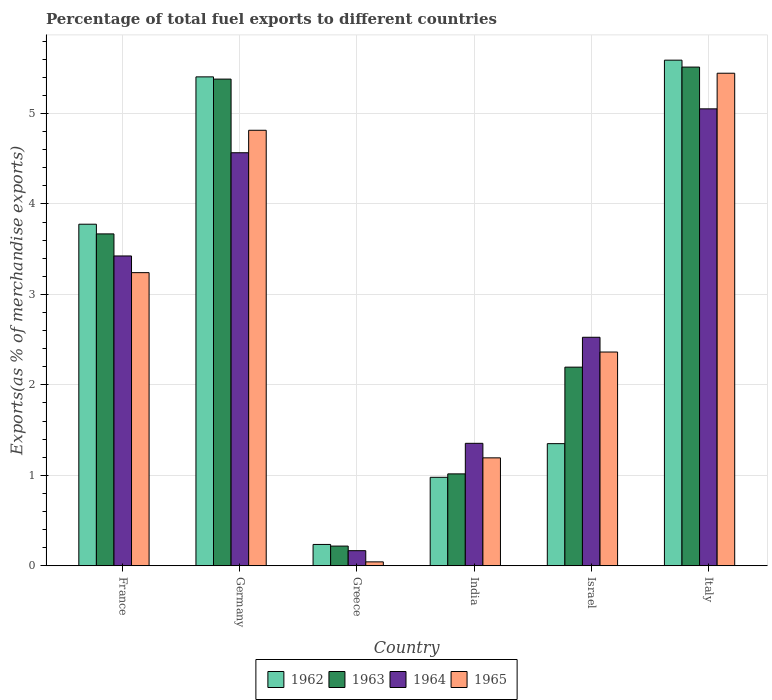How many different coloured bars are there?
Your answer should be very brief. 4. How many bars are there on the 2nd tick from the right?
Ensure brevity in your answer.  4. What is the percentage of exports to different countries in 1963 in France?
Your answer should be compact. 3.67. Across all countries, what is the maximum percentage of exports to different countries in 1962?
Keep it short and to the point. 5.59. Across all countries, what is the minimum percentage of exports to different countries in 1962?
Your answer should be compact. 0.24. In which country was the percentage of exports to different countries in 1965 minimum?
Offer a terse response. Greece. What is the total percentage of exports to different countries in 1962 in the graph?
Provide a succinct answer. 17.34. What is the difference between the percentage of exports to different countries in 1962 in India and that in Italy?
Offer a very short reply. -4.61. What is the difference between the percentage of exports to different countries in 1962 in Israel and the percentage of exports to different countries in 1965 in India?
Give a very brief answer. 0.16. What is the average percentage of exports to different countries in 1965 per country?
Offer a terse response. 2.85. What is the difference between the percentage of exports to different countries of/in 1963 and percentage of exports to different countries of/in 1962 in Israel?
Keep it short and to the point. 0.85. In how many countries, is the percentage of exports to different countries in 1965 greater than 5.4 %?
Provide a short and direct response. 1. What is the ratio of the percentage of exports to different countries in 1964 in Greece to that in Israel?
Offer a terse response. 0.07. Is the difference between the percentage of exports to different countries in 1963 in Greece and Italy greater than the difference between the percentage of exports to different countries in 1962 in Greece and Italy?
Make the answer very short. Yes. What is the difference between the highest and the second highest percentage of exports to different countries in 1965?
Provide a short and direct response. -1.57. What is the difference between the highest and the lowest percentage of exports to different countries in 1964?
Provide a short and direct response. 4.88. Is it the case that in every country, the sum of the percentage of exports to different countries in 1964 and percentage of exports to different countries in 1965 is greater than the sum of percentage of exports to different countries in 1963 and percentage of exports to different countries in 1962?
Give a very brief answer. No. What does the 3rd bar from the right in Greece represents?
Provide a succinct answer. 1963. Is it the case that in every country, the sum of the percentage of exports to different countries in 1965 and percentage of exports to different countries in 1964 is greater than the percentage of exports to different countries in 1962?
Offer a very short reply. No. How many bars are there?
Provide a succinct answer. 24. How many countries are there in the graph?
Give a very brief answer. 6. Does the graph contain any zero values?
Provide a succinct answer. No. What is the title of the graph?
Your response must be concise. Percentage of total fuel exports to different countries. Does "1993" appear as one of the legend labels in the graph?
Provide a short and direct response. No. What is the label or title of the Y-axis?
Provide a succinct answer. Exports(as % of merchandise exports). What is the Exports(as % of merchandise exports) in 1962 in France?
Ensure brevity in your answer.  3.78. What is the Exports(as % of merchandise exports) of 1963 in France?
Offer a terse response. 3.67. What is the Exports(as % of merchandise exports) of 1964 in France?
Your response must be concise. 3.43. What is the Exports(as % of merchandise exports) in 1965 in France?
Your answer should be very brief. 3.24. What is the Exports(as % of merchandise exports) in 1962 in Germany?
Offer a terse response. 5.4. What is the Exports(as % of merchandise exports) of 1963 in Germany?
Offer a terse response. 5.38. What is the Exports(as % of merchandise exports) in 1964 in Germany?
Your answer should be compact. 4.57. What is the Exports(as % of merchandise exports) in 1965 in Germany?
Give a very brief answer. 4.81. What is the Exports(as % of merchandise exports) of 1962 in Greece?
Your answer should be very brief. 0.24. What is the Exports(as % of merchandise exports) in 1963 in Greece?
Provide a succinct answer. 0.22. What is the Exports(as % of merchandise exports) in 1964 in Greece?
Your response must be concise. 0.17. What is the Exports(as % of merchandise exports) in 1965 in Greece?
Your response must be concise. 0.04. What is the Exports(as % of merchandise exports) in 1962 in India?
Offer a terse response. 0.98. What is the Exports(as % of merchandise exports) of 1963 in India?
Your answer should be very brief. 1.02. What is the Exports(as % of merchandise exports) in 1964 in India?
Provide a short and direct response. 1.35. What is the Exports(as % of merchandise exports) of 1965 in India?
Keep it short and to the point. 1.19. What is the Exports(as % of merchandise exports) in 1962 in Israel?
Give a very brief answer. 1.35. What is the Exports(as % of merchandise exports) of 1963 in Israel?
Make the answer very short. 2.2. What is the Exports(as % of merchandise exports) in 1964 in Israel?
Your response must be concise. 2.53. What is the Exports(as % of merchandise exports) of 1965 in Israel?
Give a very brief answer. 2.36. What is the Exports(as % of merchandise exports) of 1962 in Italy?
Your answer should be compact. 5.59. What is the Exports(as % of merchandise exports) of 1963 in Italy?
Ensure brevity in your answer.  5.51. What is the Exports(as % of merchandise exports) of 1964 in Italy?
Offer a very short reply. 5.05. What is the Exports(as % of merchandise exports) of 1965 in Italy?
Your answer should be compact. 5.45. Across all countries, what is the maximum Exports(as % of merchandise exports) in 1962?
Offer a very short reply. 5.59. Across all countries, what is the maximum Exports(as % of merchandise exports) of 1963?
Offer a very short reply. 5.51. Across all countries, what is the maximum Exports(as % of merchandise exports) in 1964?
Make the answer very short. 5.05. Across all countries, what is the maximum Exports(as % of merchandise exports) in 1965?
Your response must be concise. 5.45. Across all countries, what is the minimum Exports(as % of merchandise exports) of 1962?
Offer a terse response. 0.24. Across all countries, what is the minimum Exports(as % of merchandise exports) in 1963?
Offer a very short reply. 0.22. Across all countries, what is the minimum Exports(as % of merchandise exports) in 1964?
Your response must be concise. 0.17. Across all countries, what is the minimum Exports(as % of merchandise exports) in 1965?
Keep it short and to the point. 0.04. What is the total Exports(as % of merchandise exports) in 1962 in the graph?
Provide a succinct answer. 17.34. What is the total Exports(as % of merchandise exports) of 1963 in the graph?
Provide a short and direct response. 17.99. What is the total Exports(as % of merchandise exports) of 1964 in the graph?
Offer a terse response. 17.09. What is the total Exports(as % of merchandise exports) in 1965 in the graph?
Provide a short and direct response. 17.1. What is the difference between the Exports(as % of merchandise exports) in 1962 in France and that in Germany?
Give a very brief answer. -1.63. What is the difference between the Exports(as % of merchandise exports) of 1963 in France and that in Germany?
Your answer should be very brief. -1.71. What is the difference between the Exports(as % of merchandise exports) of 1964 in France and that in Germany?
Ensure brevity in your answer.  -1.14. What is the difference between the Exports(as % of merchandise exports) in 1965 in France and that in Germany?
Make the answer very short. -1.57. What is the difference between the Exports(as % of merchandise exports) in 1962 in France and that in Greece?
Your response must be concise. 3.54. What is the difference between the Exports(as % of merchandise exports) in 1963 in France and that in Greece?
Ensure brevity in your answer.  3.45. What is the difference between the Exports(as % of merchandise exports) in 1964 in France and that in Greece?
Your answer should be compact. 3.26. What is the difference between the Exports(as % of merchandise exports) of 1965 in France and that in Greece?
Give a very brief answer. 3.2. What is the difference between the Exports(as % of merchandise exports) in 1962 in France and that in India?
Your response must be concise. 2.8. What is the difference between the Exports(as % of merchandise exports) of 1963 in France and that in India?
Provide a short and direct response. 2.65. What is the difference between the Exports(as % of merchandise exports) of 1964 in France and that in India?
Your answer should be very brief. 2.07. What is the difference between the Exports(as % of merchandise exports) in 1965 in France and that in India?
Offer a terse response. 2.05. What is the difference between the Exports(as % of merchandise exports) of 1962 in France and that in Israel?
Offer a very short reply. 2.43. What is the difference between the Exports(as % of merchandise exports) of 1963 in France and that in Israel?
Give a very brief answer. 1.47. What is the difference between the Exports(as % of merchandise exports) in 1964 in France and that in Israel?
Your answer should be compact. 0.9. What is the difference between the Exports(as % of merchandise exports) of 1965 in France and that in Israel?
Give a very brief answer. 0.88. What is the difference between the Exports(as % of merchandise exports) of 1962 in France and that in Italy?
Give a very brief answer. -1.81. What is the difference between the Exports(as % of merchandise exports) in 1963 in France and that in Italy?
Ensure brevity in your answer.  -1.84. What is the difference between the Exports(as % of merchandise exports) of 1964 in France and that in Italy?
Your answer should be very brief. -1.63. What is the difference between the Exports(as % of merchandise exports) in 1965 in France and that in Italy?
Offer a terse response. -2.2. What is the difference between the Exports(as % of merchandise exports) in 1962 in Germany and that in Greece?
Provide a short and direct response. 5.17. What is the difference between the Exports(as % of merchandise exports) in 1963 in Germany and that in Greece?
Your answer should be compact. 5.16. What is the difference between the Exports(as % of merchandise exports) in 1964 in Germany and that in Greece?
Your answer should be compact. 4.4. What is the difference between the Exports(as % of merchandise exports) of 1965 in Germany and that in Greece?
Your answer should be compact. 4.77. What is the difference between the Exports(as % of merchandise exports) in 1962 in Germany and that in India?
Make the answer very short. 4.43. What is the difference between the Exports(as % of merchandise exports) in 1963 in Germany and that in India?
Give a very brief answer. 4.36. What is the difference between the Exports(as % of merchandise exports) of 1964 in Germany and that in India?
Your answer should be compact. 3.21. What is the difference between the Exports(as % of merchandise exports) in 1965 in Germany and that in India?
Provide a short and direct response. 3.62. What is the difference between the Exports(as % of merchandise exports) of 1962 in Germany and that in Israel?
Give a very brief answer. 4.05. What is the difference between the Exports(as % of merchandise exports) in 1963 in Germany and that in Israel?
Give a very brief answer. 3.18. What is the difference between the Exports(as % of merchandise exports) in 1964 in Germany and that in Israel?
Ensure brevity in your answer.  2.04. What is the difference between the Exports(as % of merchandise exports) in 1965 in Germany and that in Israel?
Your response must be concise. 2.45. What is the difference between the Exports(as % of merchandise exports) in 1962 in Germany and that in Italy?
Give a very brief answer. -0.18. What is the difference between the Exports(as % of merchandise exports) in 1963 in Germany and that in Italy?
Provide a succinct answer. -0.13. What is the difference between the Exports(as % of merchandise exports) of 1964 in Germany and that in Italy?
Provide a short and direct response. -0.49. What is the difference between the Exports(as % of merchandise exports) of 1965 in Germany and that in Italy?
Offer a terse response. -0.63. What is the difference between the Exports(as % of merchandise exports) of 1962 in Greece and that in India?
Your response must be concise. -0.74. What is the difference between the Exports(as % of merchandise exports) of 1963 in Greece and that in India?
Provide a short and direct response. -0.8. What is the difference between the Exports(as % of merchandise exports) in 1964 in Greece and that in India?
Offer a terse response. -1.19. What is the difference between the Exports(as % of merchandise exports) of 1965 in Greece and that in India?
Your response must be concise. -1.15. What is the difference between the Exports(as % of merchandise exports) in 1962 in Greece and that in Israel?
Provide a short and direct response. -1.11. What is the difference between the Exports(as % of merchandise exports) of 1963 in Greece and that in Israel?
Provide a succinct answer. -1.98. What is the difference between the Exports(as % of merchandise exports) in 1964 in Greece and that in Israel?
Make the answer very short. -2.36. What is the difference between the Exports(as % of merchandise exports) of 1965 in Greece and that in Israel?
Keep it short and to the point. -2.32. What is the difference between the Exports(as % of merchandise exports) of 1962 in Greece and that in Italy?
Give a very brief answer. -5.35. What is the difference between the Exports(as % of merchandise exports) of 1963 in Greece and that in Italy?
Provide a succinct answer. -5.3. What is the difference between the Exports(as % of merchandise exports) in 1964 in Greece and that in Italy?
Keep it short and to the point. -4.88. What is the difference between the Exports(as % of merchandise exports) in 1965 in Greece and that in Italy?
Ensure brevity in your answer.  -5.4. What is the difference between the Exports(as % of merchandise exports) of 1962 in India and that in Israel?
Provide a short and direct response. -0.37. What is the difference between the Exports(as % of merchandise exports) in 1963 in India and that in Israel?
Provide a short and direct response. -1.18. What is the difference between the Exports(as % of merchandise exports) of 1964 in India and that in Israel?
Provide a short and direct response. -1.17. What is the difference between the Exports(as % of merchandise exports) in 1965 in India and that in Israel?
Keep it short and to the point. -1.17. What is the difference between the Exports(as % of merchandise exports) of 1962 in India and that in Italy?
Keep it short and to the point. -4.61. What is the difference between the Exports(as % of merchandise exports) of 1963 in India and that in Italy?
Keep it short and to the point. -4.5. What is the difference between the Exports(as % of merchandise exports) of 1964 in India and that in Italy?
Ensure brevity in your answer.  -3.7. What is the difference between the Exports(as % of merchandise exports) in 1965 in India and that in Italy?
Offer a very short reply. -4.25. What is the difference between the Exports(as % of merchandise exports) in 1962 in Israel and that in Italy?
Ensure brevity in your answer.  -4.24. What is the difference between the Exports(as % of merchandise exports) in 1963 in Israel and that in Italy?
Give a very brief answer. -3.32. What is the difference between the Exports(as % of merchandise exports) in 1964 in Israel and that in Italy?
Keep it short and to the point. -2.53. What is the difference between the Exports(as % of merchandise exports) in 1965 in Israel and that in Italy?
Give a very brief answer. -3.08. What is the difference between the Exports(as % of merchandise exports) in 1962 in France and the Exports(as % of merchandise exports) in 1963 in Germany?
Offer a terse response. -1.6. What is the difference between the Exports(as % of merchandise exports) of 1962 in France and the Exports(as % of merchandise exports) of 1964 in Germany?
Your answer should be very brief. -0.79. What is the difference between the Exports(as % of merchandise exports) in 1962 in France and the Exports(as % of merchandise exports) in 1965 in Germany?
Give a very brief answer. -1.04. What is the difference between the Exports(as % of merchandise exports) in 1963 in France and the Exports(as % of merchandise exports) in 1964 in Germany?
Give a very brief answer. -0.9. What is the difference between the Exports(as % of merchandise exports) of 1963 in France and the Exports(as % of merchandise exports) of 1965 in Germany?
Offer a very short reply. -1.15. What is the difference between the Exports(as % of merchandise exports) of 1964 in France and the Exports(as % of merchandise exports) of 1965 in Germany?
Offer a terse response. -1.39. What is the difference between the Exports(as % of merchandise exports) of 1962 in France and the Exports(as % of merchandise exports) of 1963 in Greece?
Your answer should be very brief. 3.56. What is the difference between the Exports(as % of merchandise exports) of 1962 in France and the Exports(as % of merchandise exports) of 1964 in Greece?
Offer a very short reply. 3.61. What is the difference between the Exports(as % of merchandise exports) in 1962 in France and the Exports(as % of merchandise exports) in 1965 in Greece?
Provide a short and direct response. 3.73. What is the difference between the Exports(as % of merchandise exports) in 1963 in France and the Exports(as % of merchandise exports) in 1964 in Greece?
Provide a short and direct response. 3.5. What is the difference between the Exports(as % of merchandise exports) in 1963 in France and the Exports(as % of merchandise exports) in 1965 in Greece?
Your response must be concise. 3.63. What is the difference between the Exports(as % of merchandise exports) of 1964 in France and the Exports(as % of merchandise exports) of 1965 in Greece?
Keep it short and to the point. 3.38. What is the difference between the Exports(as % of merchandise exports) in 1962 in France and the Exports(as % of merchandise exports) in 1963 in India?
Give a very brief answer. 2.76. What is the difference between the Exports(as % of merchandise exports) of 1962 in France and the Exports(as % of merchandise exports) of 1964 in India?
Ensure brevity in your answer.  2.42. What is the difference between the Exports(as % of merchandise exports) in 1962 in France and the Exports(as % of merchandise exports) in 1965 in India?
Offer a terse response. 2.58. What is the difference between the Exports(as % of merchandise exports) in 1963 in France and the Exports(as % of merchandise exports) in 1964 in India?
Provide a short and direct response. 2.32. What is the difference between the Exports(as % of merchandise exports) of 1963 in France and the Exports(as % of merchandise exports) of 1965 in India?
Your response must be concise. 2.48. What is the difference between the Exports(as % of merchandise exports) of 1964 in France and the Exports(as % of merchandise exports) of 1965 in India?
Provide a short and direct response. 2.23. What is the difference between the Exports(as % of merchandise exports) in 1962 in France and the Exports(as % of merchandise exports) in 1963 in Israel?
Your response must be concise. 1.58. What is the difference between the Exports(as % of merchandise exports) in 1962 in France and the Exports(as % of merchandise exports) in 1964 in Israel?
Your answer should be very brief. 1.25. What is the difference between the Exports(as % of merchandise exports) of 1962 in France and the Exports(as % of merchandise exports) of 1965 in Israel?
Offer a very short reply. 1.41. What is the difference between the Exports(as % of merchandise exports) in 1963 in France and the Exports(as % of merchandise exports) in 1964 in Israel?
Your answer should be compact. 1.14. What is the difference between the Exports(as % of merchandise exports) in 1963 in France and the Exports(as % of merchandise exports) in 1965 in Israel?
Ensure brevity in your answer.  1.31. What is the difference between the Exports(as % of merchandise exports) in 1964 in France and the Exports(as % of merchandise exports) in 1965 in Israel?
Your response must be concise. 1.06. What is the difference between the Exports(as % of merchandise exports) of 1962 in France and the Exports(as % of merchandise exports) of 1963 in Italy?
Offer a very short reply. -1.74. What is the difference between the Exports(as % of merchandise exports) in 1962 in France and the Exports(as % of merchandise exports) in 1964 in Italy?
Your answer should be very brief. -1.28. What is the difference between the Exports(as % of merchandise exports) of 1962 in France and the Exports(as % of merchandise exports) of 1965 in Italy?
Provide a succinct answer. -1.67. What is the difference between the Exports(as % of merchandise exports) in 1963 in France and the Exports(as % of merchandise exports) in 1964 in Italy?
Your answer should be compact. -1.38. What is the difference between the Exports(as % of merchandise exports) in 1963 in France and the Exports(as % of merchandise exports) in 1965 in Italy?
Your answer should be very brief. -1.78. What is the difference between the Exports(as % of merchandise exports) in 1964 in France and the Exports(as % of merchandise exports) in 1965 in Italy?
Give a very brief answer. -2.02. What is the difference between the Exports(as % of merchandise exports) in 1962 in Germany and the Exports(as % of merchandise exports) in 1963 in Greece?
Your answer should be compact. 5.19. What is the difference between the Exports(as % of merchandise exports) of 1962 in Germany and the Exports(as % of merchandise exports) of 1964 in Greece?
Make the answer very short. 5.24. What is the difference between the Exports(as % of merchandise exports) in 1962 in Germany and the Exports(as % of merchandise exports) in 1965 in Greece?
Your answer should be very brief. 5.36. What is the difference between the Exports(as % of merchandise exports) of 1963 in Germany and the Exports(as % of merchandise exports) of 1964 in Greece?
Provide a succinct answer. 5.21. What is the difference between the Exports(as % of merchandise exports) of 1963 in Germany and the Exports(as % of merchandise exports) of 1965 in Greece?
Provide a short and direct response. 5.34. What is the difference between the Exports(as % of merchandise exports) of 1964 in Germany and the Exports(as % of merchandise exports) of 1965 in Greece?
Offer a very short reply. 4.52. What is the difference between the Exports(as % of merchandise exports) of 1962 in Germany and the Exports(as % of merchandise exports) of 1963 in India?
Your response must be concise. 4.39. What is the difference between the Exports(as % of merchandise exports) in 1962 in Germany and the Exports(as % of merchandise exports) in 1964 in India?
Offer a very short reply. 4.05. What is the difference between the Exports(as % of merchandise exports) in 1962 in Germany and the Exports(as % of merchandise exports) in 1965 in India?
Ensure brevity in your answer.  4.21. What is the difference between the Exports(as % of merchandise exports) in 1963 in Germany and the Exports(as % of merchandise exports) in 1964 in India?
Offer a terse response. 4.03. What is the difference between the Exports(as % of merchandise exports) in 1963 in Germany and the Exports(as % of merchandise exports) in 1965 in India?
Offer a very short reply. 4.19. What is the difference between the Exports(as % of merchandise exports) in 1964 in Germany and the Exports(as % of merchandise exports) in 1965 in India?
Give a very brief answer. 3.37. What is the difference between the Exports(as % of merchandise exports) of 1962 in Germany and the Exports(as % of merchandise exports) of 1963 in Israel?
Your answer should be very brief. 3.21. What is the difference between the Exports(as % of merchandise exports) of 1962 in Germany and the Exports(as % of merchandise exports) of 1964 in Israel?
Keep it short and to the point. 2.88. What is the difference between the Exports(as % of merchandise exports) of 1962 in Germany and the Exports(as % of merchandise exports) of 1965 in Israel?
Make the answer very short. 3.04. What is the difference between the Exports(as % of merchandise exports) of 1963 in Germany and the Exports(as % of merchandise exports) of 1964 in Israel?
Offer a very short reply. 2.85. What is the difference between the Exports(as % of merchandise exports) in 1963 in Germany and the Exports(as % of merchandise exports) in 1965 in Israel?
Your answer should be compact. 3.02. What is the difference between the Exports(as % of merchandise exports) of 1964 in Germany and the Exports(as % of merchandise exports) of 1965 in Israel?
Your answer should be compact. 2.2. What is the difference between the Exports(as % of merchandise exports) in 1962 in Germany and the Exports(as % of merchandise exports) in 1963 in Italy?
Provide a short and direct response. -0.11. What is the difference between the Exports(as % of merchandise exports) in 1962 in Germany and the Exports(as % of merchandise exports) in 1964 in Italy?
Provide a succinct answer. 0.35. What is the difference between the Exports(as % of merchandise exports) of 1962 in Germany and the Exports(as % of merchandise exports) of 1965 in Italy?
Your answer should be very brief. -0.04. What is the difference between the Exports(as % of merchandise exports) of 1963 in Germany and the Exports(as % of merchandise exports) of 1964 in Italy?
Your response must be concise. 0.33. What is the difference between the Exports(as % of merchandise exports) in 1963 in Germany and the Exports(as % of merchandise exports) in 1965 in Italy?
Give a very brief answer. -0.06. What is the difference between the Exports(as % of merchandise exports) of 1964 in Germany and the Exports(as % of merchandise exports) of 1965 in Italy?
Provide a succinct answer. -0.88. What is the difference between the Exports(as % of merchandise exports) in 1962 in Greece and the Exports(as % of merchandise exports) in 1963 in India?
Make the answer very short. -0.78. What is the difference between the Exports(as % of merchandise exports) of 1962 in Greece and the Exports(as % of merchandise exports) of 1964 in India?
Your answer should be compact. -1.12. What is the difference between the Exports(as % of merchandise exports) of 1962 in Greece and the Exports(as % of merchandise exports) of 1965 in India?
Your answer should be very brief. -0.96. What is the difference between the Exports(as % of merchandise exports) of 1963 in Greece and the Exports(as % of merchandise exports) of 1964 in India?
Keep it short and to the point. -1.14. What is the difference between the Exports(as % of merchandise exports) of 1963 in Greece and the Exports(as % of merchandise exports) of 1965 in India?
Give a very brief answer. -0.98. What is the difference between the Exports(as % of merchandise exports) of 1964 in Greece and the Exports(as % of merchandise exports) of 1965 in India?
Your answer should be very brief. -1.03. What is the difference between the Exports(as % of merchandise exports) of 1962 in Greece and the Exports(as % of merchandise exports) of 1963 in Israel?
Keep it short and to the point. -1.96. What is the difference between the Exports(as % of merchandise exports) of 1962 in Greece and the Exports(as % of merchandise exports) of 1964 in Israel?
Provide a short and direct response. -2.29. What is the difference between the Exports(as % of merchandise exports) of 1962 in Greece and the Exports(as % of merchandise exports) of 1965 in Israel?
Keep it short and to the point. -2.13. What is the difference between the Exports(as % of merchandise exports) in 1963 in Greece and the Exports(as % of merchandise exports) in 1964 in Israel?
Offer a very short reply. -2.31. What is the difference between the Exports(as % of merchandise exports) in 1963 in Greece and the Exports(as % of merchandise exports) in 1965 in Israel?
Provide a succinct answer. -2.15. What is the difference between the Exports(as % of merchandise exports) in 1964 in Greece and the Exports(as % of merchandise exports) in 1965 in Israel?
Your response must be concise. -2.2. What is the difference between the Exports(as % of merchandise exports) of 1962 in Greece and the Exports(as % of merchandise exports) of 1963 in Italy?
Offer a very short reply. -5.28. What is the difference between the Exports(as % of merchandise exports) of 1962 in Greece and the Exports(as % of merchandise exports) of 1964 in Italy?
Your answer should be compact. -4.82. What is the difference between the Exports(as % of merchandise exports) in 1962 in Greece and the Exports(as % of merchandise exports) in 1965 in Italy?
Make the answer very short. -5.21. What is the difference between the Exports(as % of merchandise exports) in 1963 in Greece and the Exports(as % of merchandise exports) in 1964 in Italy?
Keep it short and to the point. -4.83. What is the difference between the Exports(as % of merchandise exports) in 1963 in Greece and the Exports(as % of merchandise exports) in 1965 in Italy?
Provide a succinct answer. -5.23. What is the difference between the Exports(as % of merchandise exports) of 1964 in Greece and the Exports(as % of merchandise exports) of 1965 in Italy?
Your response must be concise. -5.28. What is the difference between the Exports(as % of merchandise exports) in 1962 in India and the Exports(as % of merchandise exports) in 1963 in Israel?
Make the answer very short. -1.22. What is the difference between the Exports(as % of merchandise exports) in 1962 in India and the Exports(as % of merchandise exports) in 1964 in Israel?
Make the answer very short. -1.55. What is the difference between the Exports(as % of merchandise exports) in 1962 in India and the Exports(as % of merchandise exports) in 1965 in Israel?
Make the answer very short. -1.38. What is the difference between the Exports(as % of merchandise exports) of 1963 in India and the Exports(as % of merchandise exports) of 1964 in Israel?
Ensure brevity in your answer.  -1.51. What is the difference between the Exports(as % of merchandise exports) in 1963 in India and the Exports(as % of merchandise exports) in 1965 in Israel?
Provide a succinct answer. -1.35. What is the difference between the Exports(as % of merchandise exports) in 1964 in India and the Exports(as % of merchandise exports) in 1965 in Israel?
Provide a short and direct response. -1.01. What is the difference between the Exports(as % of merchandise exports) of 1962 in India and the Exports(as % of merchandise exports) of 1963 in Italy?
Your answer should be compact. -4.54. What is the difference between the Exports(as % of merchandise exports) in 1962 in India and the Exports(as % of merchandise exports) in 1964 in Italy?
Keep it short and to the point. -4.07. What is the difference between the Exports(as % of merchandise exports) of 1962 in India and the Exports(as % of merchandise exports) of 1965 in Italy?
Give a very brief answer. -4.47. What is the difference between the Exports(as % of merchandise exports) of 1963 in India and the Exports(as % of merchandise exports) of 1964 in Italy?
Provide a short and direct response. -4.04. What is the difference between the Exports(as % of merchandise exports) of 1963 in India and the Exports(as % of merchandise exports) of 1965 in Italy?
Ensure brevity in your answer.  -4.43. What is the difference between the Exports(as % of merchandise exports) in 1964 in India and the Exports(as % of merchandise exports) in 1965 in Italy?
Your answer should be compact. -4.09. What is the difference between the Exports(as % of merchandise exports) of 1962 in Israel and the Exports(as % of merchandise exports) of 1963 in Italy?
Make the answer very short. -4.16. What is the difference between the Exports(as % of merchandise exports) of 1962 in Israel and the Exports(as % of merchandise exports) of 1964 in Italy?
Ensure brevity in your answer.  -3.7. What is the difference between the Exports(as % of merchandise exports) in 1962 in Israel and the Exports(as % of merchandise exports) in 1965 in Italy?
Your answer should be compact. -4.09. What is the difference between the Exports(as % of merchandise exports) in 1963 in Israel and the Exports(as % of merchandise exports) in 1964 in Italy?
Your answer should be compact. -2.86. What is the difference between the Exports(as % of merchandise exports) of 1963 in Israel and the Exports(as % of merchandise exports) of 1965 in Italy?
Ensure brevity in your answer.  -3.25. What is the difference between the Exports(as % of merchandise exports) in 1964 in Israel and the Exports(as % of merchandise exports) in 1965 in Italy?
Your answer should be compact. -2.92. What is the average Exports(as % of merchandise exports) in 1962 per country?
Keep it short and to the point. 2.89. What is the average Exports(as % of merchandise exports) of 1963 per country?
Make the answer very short. 3. What is the average Exports(as % of merchandise exports) of 1964 per country?
Provide a short and direct response. 2.85. What is the average Exports(as % of merchandise exports) of 1965 per country?
Offer a terse response. 2.85. What is the difference between the Exports(as % of merchandise exports) in 1962 and Exports(as % of merchandise exports) in 1963 in France?
Your answer should be compact. 0.11. What is the difference between the Exports(as % of merchandise exports) in 1962 and Exports(as % of merchandise exports) in 1964 in France?
Offer a very short reply. 0.35. What is the difference between the Exports(as % of merchandise exports) in 1962 and Exports(as % of merchandise exports) in 1965 in France?
Offer a terse response. 0.54. What is the difference between the Exports(as % of merchandise exports) in 1963 and Exports(as % of merchandise exports) in 1964 in France?
Your answer should be very brief. 0.24. What is the difference between the Exports(as % of merchandise exports) in 1963 and Exports(as % of merchandise exports) in 1965 in France?
Keep it short and to the point. 0.43. What is the difference between the Exports(as % of merchandise exports) in 1964 and Exports(as % of merchandise exports) in 1965 in France?
Make the answer very short. 0.18. What is the difference between the Exports(as % of merchandise exports) in 1962 and Exports(as % of merchandise exports) in 1963 in Germany?
Offer a very short reply. 0.02. What is the difference between the Exports(as % of merchandise exports) in 1962 and Exports(as % of merchandise exports) in 1964 in Germany?
Your answer should be very brief. 0.84. What is the difference between the Exports(as % of merchandise exports) of 1962 and Exports(as % of merchandise exports) of 1965 in Germany?
Provide a succinct answer. 0.59. What is the difference between the Exports(as % of merchandise exports) of 1963 and Exports(as % of merchandise exports) of 1964 in Germany?
Your response must be concise. 0.81. What is the difference between the Exports(as % of merchandise exports) of 1963 and Exports(as % of merchandise exports) of 1965 in Germany?
Make the answer very short. 0.57. What is the difference between the Exports(as % of merchandise exports) in 1964 and Exports(as % of merchandise exports) in 1965 in Germany?
Your answer should be compact. -0.25. What is the difference between the Exports(as % of merchandise exports) in 1962 and Exports(as % of merchandise exports) in 1963 in Greece?
Make the answer very short. 0.02. What is the difference between the Exports(as % of merchandise exports) of 1962 and Exports(as % of merchandise exports) of 1964 in Greece?
Make the answer very short. 0.07. What is the difference between the Exports(as % of merchandise exports) in 1962 and Exports(as % of merchandise exports) in 1965 in Greece?
Offer a terse response. 0.19. What is the difference between the Exports(as % of merchandise exports) of 1963 and Exports(as % of merchandise exports) of 1964 in Greece?
Your response must be concise. 0.05. What is the difference between the Exports(as % of merchandise exports) in 1963 and Exports(as % of merchandise exports) in 1965 in Greece?
Offer a very short reply. 0.17. What is the difference between the Exports(as % of merchandise exports) in 1964 and Exports(as % of merchandise exports) in 1965 in Greece?
Offer a terse response. 0.12. What is the difference between the Exports(as % of merchandise exports) of 1962 and Exports(as % of merchandise exports) of 1963 in India?
Offer a terse response. -0.04. What is the difference between the Exports(as % of merchandise exports) in 1962 and Exports(as % of merchandise exports) in 1964 in India?
Offer a very short reply. -0.38. What is the difference between the Exports(as % of merchandise exports) in 1962 and Exports(as % of merchandise exports) in 1965 in India?
Your answer should be compact. -0.22. What is the difference between the Exports(as % of merchandise exports) of 1963 and Exports(as % of merchandise exports) of 1964 in India?
Provide a succinct answer. -0.34. What is the difference between the Exports(as % of merchandise exports) in 1963 and Exports(as % of merchandise exports) in 1965 in India?
Ensure brevity in your answer.  -0.18. What is the difference between the Exports(as % of merchandise exports) of 1964 and Exports(as % of merchandise exports) of 1965 in India?
Ensure brevity in your answer.  0.16. What is the difference between the Exports(as % of merchandise exports) of 1962 and Exports(as % of merchandise exports) of 1963 in Israel?
Provide a succinct answer. -0.85. What is the difference between the Exports(as % of merchandise exports) in 1962 and Exports(as % of merchandise exports) in 1964 in Israel?
Keep it short and to the point. -1.18. What is the difference between the Exports(as % of merchandise exports) of 1962 and Exports(as % of merchandise exports) of 1965 in Israel?
Provide a short and direct response. -1.01. What is the difference between the Exports(as % of merchandise exports) in 1963 and Exports(as % of merchandise exports) in 1964 in Israel?
Offer a terse response. -0.33. What is the difference between the Exports(as % of merchandise exports) of 1963 and Exports(as % of merchandise exports) of 1965 in Israel?
Make the answer very short. -0.17. What is the difference between the Exports(as % of merchandise exports) in 1964 and Exports(as % of merchandise exports) in 1965 in Israel?
Offer a very short reply. 0.16. What is the difference between the Exports(as % of merchandise exports) of 1962 and Exports(as % of merchandise exports) of 1963 in Italy?
Offer a very short reply. 0.08. What is the difference between the Exports(as % of merchandise exports) in 1962 and Exports(as % of merchandise exports) in 1964 in Italy?
Offer a terse response. 0.54. What is the difference between the Exports(as % of merchandise exports) in 1962 and Exports(as % of merchandise exports) in 1965 in Italy?
Offer a terse response. 0.14. What is the difference between the Exports(as % of merchandise exports) in 1963 and Exports(as % of merchandise exports) in 1964 in Italy?
Your answer should be compact. 0.46. What is the difference between the Exports(as % of merchandise exports) of 1963 and Exports(as % of merchandise exports) of 1965 in Italy?
Offer a terse response. 0.07. What is the difference between the Exports(as % of merchandise exports) in 1964 and Exports(as % of merchandise exports) in 1965 in Italy?
Provide a succinct answer. -0.39. What is the ratio of the Exports(as % of merchandise exports) of 1962 in France to that in Germany?
Provide a short and direct response. 0.7. What is the ratio of the Exports(as % of merchandise exports) of 1963 in France to that in Germany?
Offer a very short reply. 0.68. What is the ratio of the Exports(as % of merchandise exports) of 1964 in France to that in Germany?
Provide a short and direct response. 0.75. What is the ratio of the Exports(as % of merchandise exports) of 1965 in France to that in Germany?
Offer a very short reply. 0.67. What is the ratio of the Exports(as % of merchandise exports) in 1962 in France to that in Greece?
Offer a very short reply. 16.01. What is the ratio of the Exports(as % of merchandise exports) in 1963 in France to that in Greece?
Your response must be concise. 16.85. What is the ratio of the Exports(as % of merchandise exports) of 1964 in France to that in Greece?
Ensure brevity in your answer.  20.5. What is the ratio of the Exports(as % of merchandise exports) of 1965 in France to that in Greece?
Your answer should be very brief. 74.69. What is the ratio of the Exports(as % of merchandise exports) in 1962 in France to that in India?
Provide a succinct answer. 3.86. What is the ratio of the Exports(as % of merchandise exports) in 1963 in France to that in India?
Your response must be concise. 3.61. What is the ratio of the Exports(as % of merchandise exports) of 1964 in France to that in India?
Your response must be concise. 2.53. What is the ratio of the Exports(as % of merchandise exports) in 1965 in France to that in India?
Offer a terse response. 2.72. What is the ratio of the Exports(as % of merchandise exports) of 1962 in France to that in Israel?
Your response must be concise. 2.8. What is the ratio of the Exports(as % of merchandise exports) in 1963 in France to that in Israel?
Provide a short and direct response. 1.67. What is the ratio of the Exports(as % of merchandise exports) in 1964 in France to that in Israel?
Make the answer very short. 1.36. What is the ratio of the Exports(as % of merchandise exports) in 1965 in France to that in Israel?
Make the answer very short. 1.37. What is the ratio of the Exports(as % of merchandise exports) of 1962 in France to that in Italy?
Provide a succinct answer. 0.68. What is the ratio of the Exports(as % of merchandise exports) in 1963 in France to that in Italy?
Provide a short and direct response. 0.67. What is the ratio of the Exports(as % of merchandise exports) in 1964 in France to that in Italy?
Your response must be concise. 0.68. What is the ratio of the Exports(as % of merchandise exports) in 1965 in France to that in Italy?
Your response must be concise. 0.6. What is the ratio of the Exports(as % of merchandise exports) in 1962 in Germany to that in Greece?
Make the answer very short. 22.91. What is the ratio of the Exports(as % of merchandise exports) in 1963 in Germany to that in Greece?
Offer a very short reply. 24.71. What is the ratio of the Exports(as % of merchandise exports) of 1964 in Germany to that in Greece?
Your answer should be very brief. 27.34. What is the ratio of the Exports(as % of merchandise exports) of 1965 in Germany to that in Greece?
Your answer should be compact. 110.96. What is the ratio of the Exports(as % of merchandise exports) of 1962 in Germany to that in India?
Offer a very short reply. 5.53. What is the ratio of the Exports(as % of merchandise exports) of 1963 in Germany to that in India?
Your answer should be very brief. 5.3. What is the ratio of the Exports(as % of merchandise exports) in 1964 in Germany to that in India?
Make the answer very short. 3.37. What is the ratio of the Exports(as % of merchandise exports) in 1965 in Germany to that in India?
Offer a terse response. 4.03. What is the ratio of the Exports(as % of merchandise exports) of 1962 in Germany to that in Israel?
Offer a terse response. 4. What is the ratio of the Exports(as % of merchandise exports) in 1963 in Germany to that in Israel?
Ensure brevity in your answer.  2.45. What is the ratio of the Exports(as % of merchandise exports) in 1964 in Germany to that in Israel?
Keep it short and to the point. 1.81. What is the ratio of the Exports(as % of merchandise exports) in 1965 in Germany to that in Israel?
Provide a succinct answer. 2.04. What is the ratio of the Exports(as % of merchandise exports) in 1962 in Germany to that in Italy?
Your answer should be very brief. 0.97. What is the ratio of the Exports(as % of merchandise exports) of 1963 in Germany to that in Italy?
Make the answer very short. 0.98. What is the ratio of the Exports(as % of merchandise exports) of 1964 in Germany to that in Italy?
Make the answer very short. 0.9. What is the ratio of the Exports(as % of merchandise exports) in 1965 in Germany to that in Italy?
Your answer should be compact. 0.88. What is the ratio of the Exports(as % of merchandise exports) in 1962 in Greece to that in India?
Keep it short and to the point. 0.24. What is the ratio of the Exports(as % of merchandise exports) of 1963 in Greece to that in India?
Provide a short and direct response. 0.21. What is the ratio of the Exports(as % of merchandise exports) of 1964 in Greece to that in India?
Keep it short and to the point. 0.12. What is the ratio of the Exports(as % of merchandise exports) of 1965 in Greece to that in India?
Give a very brief answer. 0.04. What is the ratio of the Exports(as % of merchandise exports) of 1962 in Greece to that in Israel?
Your response must be concise. 0.17. What is the ratio of the Exports(as % of merchandise exports) of 1963 in Greece to that in Israel?
Offer a terse response. 0.1. What is the ratio of the Exports(as % of merchandise exports) in 1964 in Greece to that in Israel?
Give a very brief answer. 0.07. What is the ratio of the Exports(as % of merchandise exports) of 1965 in Greece to that in Israel?
Provide a succinct answer. 0.02. What is the ratio of the Exports(as % of merchandise exports) of 1962 in Greece to that in Italy?
Offer a terse response. 0.04. What is the ratio of the Exports(as % of merchandise exports) of 1963 in Greece to that in Italy?
Your response must be concise. 0.04. What is the ratio of the Exports(as % of merchandise exports) in 1964 in Greece to that in Italy?
Your answer should be compact. 0.03. What is the ratio of the Exports(as % of merchandise exports) in 1965 in Greece to that in Italy?
Provide a short and direct response. 0.01. What is the ratio of the Exports(as % of merchandise exports) in 1962 in India to that in Israel?
Provide a succinct answer. 0.72. What is the ratio of the Exports(as % of merchandise exports) of 1963 in India to that in Israel?
Provide a succinct answer. 0.46. What is the ratio of the Exports(as % of merchandise exports) in 1964 in India to that in Israel?
Make the answer very short. 0.54. What is the ratio of the Exports(as % of merchandise exports) of 1965 in India to that in Israel?
Your response must be concise. 0.51. What is the ratio of the Exports(as % of merchandise exports) in 1962 in India to that in Italy?
Provide a succinct answer. 0.17. What is the ratio of the Exports(as % of merchandise exports) in 1963 in India to that in Italy?
Ensure brevity in your answer.  0.18. What is the ratio of the Exports(as % of merchandise exports) of 1964 in India to that in Italy?
Your answer should be compact. 0.27. What is the ratio of the Exports(as % of merchandise exports) of 1965 in India to that in Italy?
Give a very brief answer. 0.22. What is the ratio of the Exports(as % of merchandise exports) in 1962 in Israel to that in Italy?
Provide a short and direct response. 0.24. What is the ratio of the Exports(as % of merchandise exports) of 1963 in Israel to that in Italy?
Your answer should be compact. 0.4. What is the ratio of the Exports(as % of merchandise exports) in 1964 in Israel to that in Italy?
Provide a short and direct response. 0.5. What is the ratio of the Exports(as % of merchandise exports) of 1965 in Israel to that in Italy?
Your answer should be very brief. 0.43. What is the difference between the highest and the second highest Exports(as % of merchandise exports) in 1962?
Provide a short and direct response. 0.18. What is the difference between the highest and the second highest Exports(as % of merchandise exports) of 1963?
Ensure brevity in your answer.  0.13. What is the difference between the highest and the second highest Exports(as % of merchandise exports) of 1964?
Provide a succinct answer. 0.49. What is the difference between the highest and the second highest Exports(as % of merchandise exports) in 1965?
Ensure brevity in your answer.  0.63. What is the difference between the highest and the lowest Exports(as % of merchandise exports) of 1962?
Your answer should be compact. 5.35. What is the difference between the highest and the lowest Exports(as % of merchandise exports) of 1963?
Your answer should be compact. 5.3. What is the difference between the highest and the lowest Exports(as % of merchandise exports) in 1964?
Your answer should be very brief. 4.88. What is the difference between the highest and the lowest Exports(as % of merchandise exports) in 1965?
Provide a short and direct response. 5.4. 